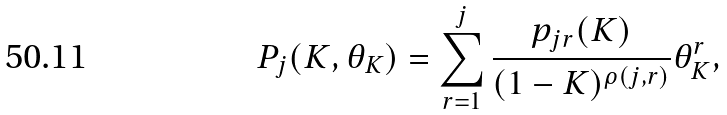<formula> <loc_0><loc_0><loc_500><loc_500>P _ { j } ( K , \theta _ { K } ) = \sum _ { r = 1 } ^ { j } \frac { p _ { j r } ( K ) } { ( 1 - K ) ^ { \rho ( j , r ) } } \theta _ { K } ^ { r } ,</formula> 